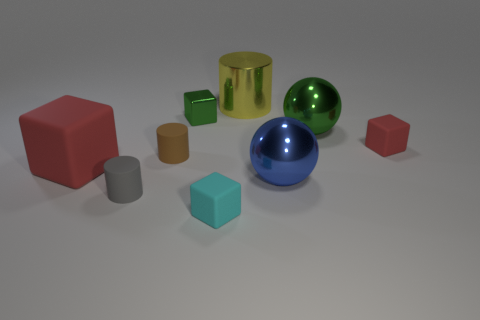Is the number of green shiny cubes that are right of the small gray matte cylinder greater than the number of gray matte things on the right side of the big green metallic sphere?
Offer a very short reply. Yes. Is there a small brown matte object of the same shape as the tiny green metallic thing?
Your response must be concise. No. There is a red matte object that is the same size as the blue metal sphere; what is its shape?
Keep it short and to the point. Cube. The large metallic object that is behind the metallic cube has what shape?
Give a very brief answer. Cylinder. Is the number of tiny matte cubes in front of the large red rubber block less than the number of tiny things to the left of the large blue shiny object?
Provide a short and direct response. Yes. Is the size of the green shiny block the same as the green shiny object that is right of the big yellow metal cylinder?
Your answer should be compact. No. How many other red blocks are the same size as the shiny cube?
Provide a short and direct response. 1. What is the color of the big thing that is made of the same material as the tiny gray object?
Your response must be concise. Red. Is the number of small red objects greater than the number of green metallic objects?
Make the answer very short. No. Does the blue sphere have the same material as the gray cylinder?
Your answer should be compact. No. 